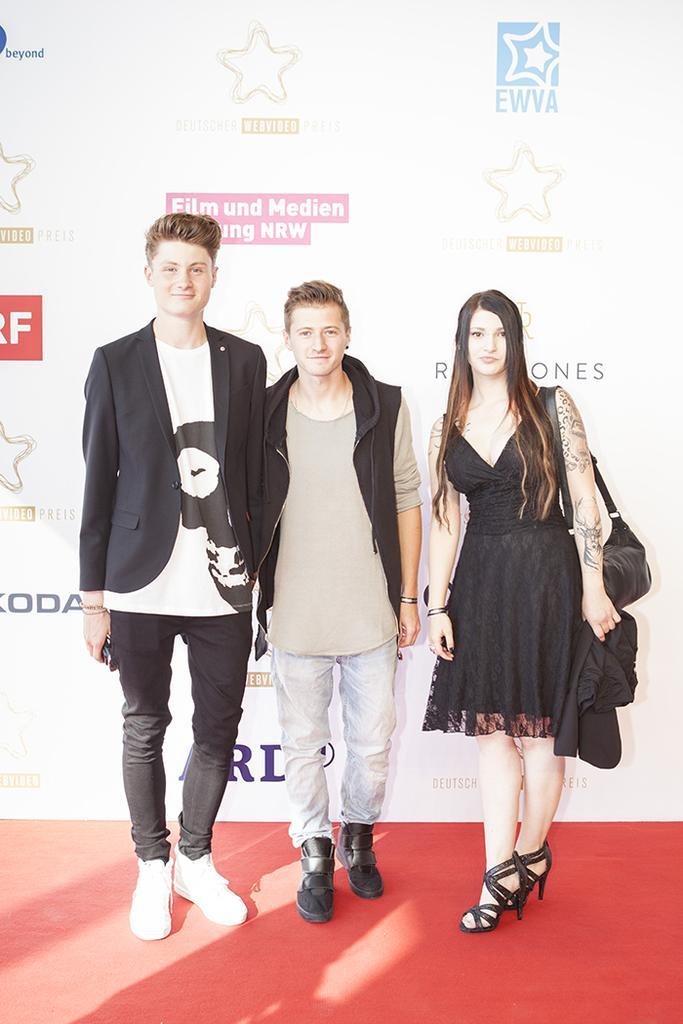Please provide a concise description of this image. In the picture we can see a three people, two men and a woman standing on the floor, which is red in color and a woman is wearing a black dress with a heels and hand bag and a men are with jacket and blazer and in the background we can see a wall with some advertisements to it. 